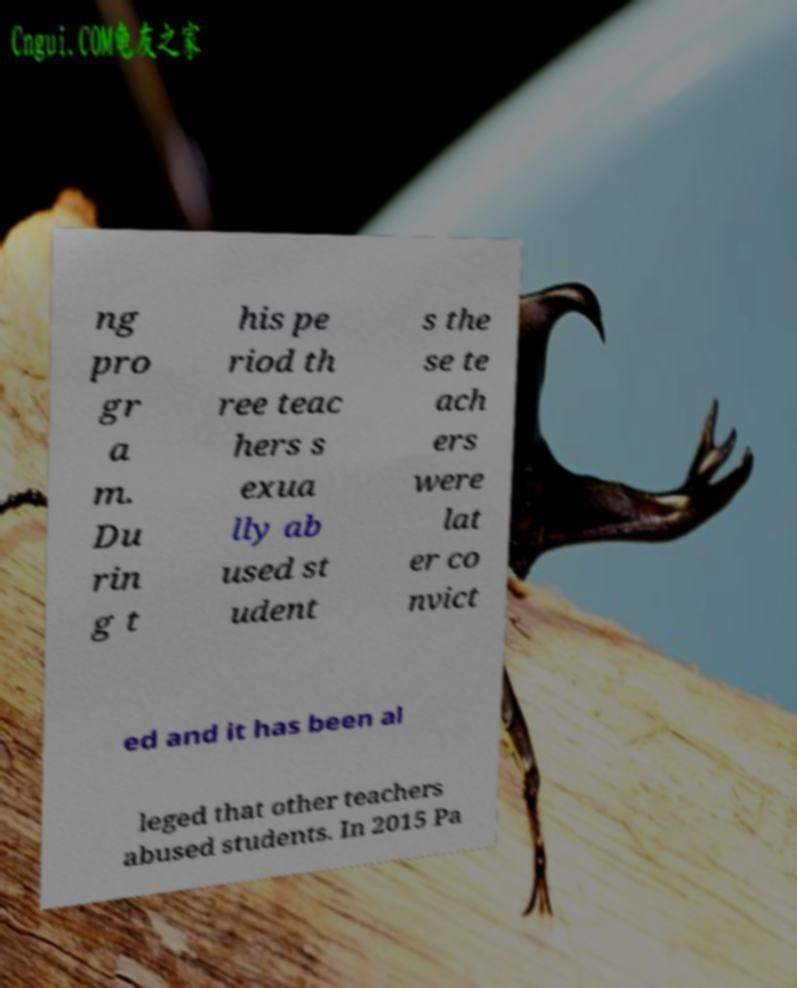Please identify and transcribe the text found in this image. ng pro gr a m. Du rin g t his pe riod th ree teac hers s exua lly ab used st udent s the se te ach ers were lat er co nvict ed and it has been al leged that other teachers abused students. In 2015 Pa 